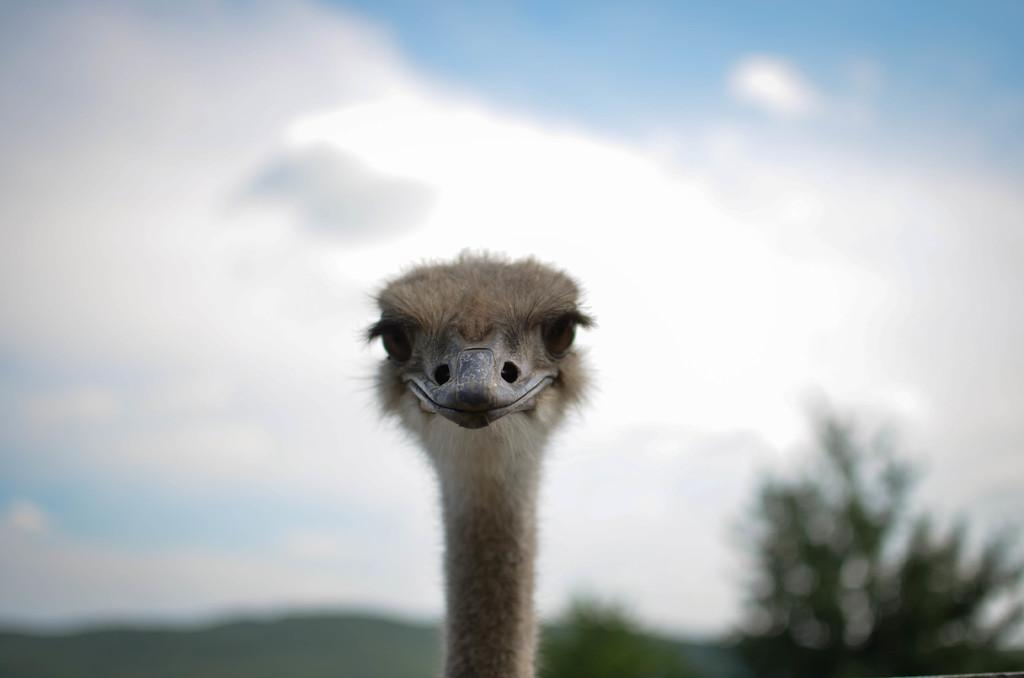What type of animal is in the front of the image? The specific type of animal cannot be determined from the provided facts. What can be seen in the background of the image? There are trees in the background of the image. How would you describe the sky in the image? The sky is cloudy in the image. What flavor of mint is the animal chewing on in the image? There is no mint or indication of chewing in the image; it only shows an animal and trees in the background. 